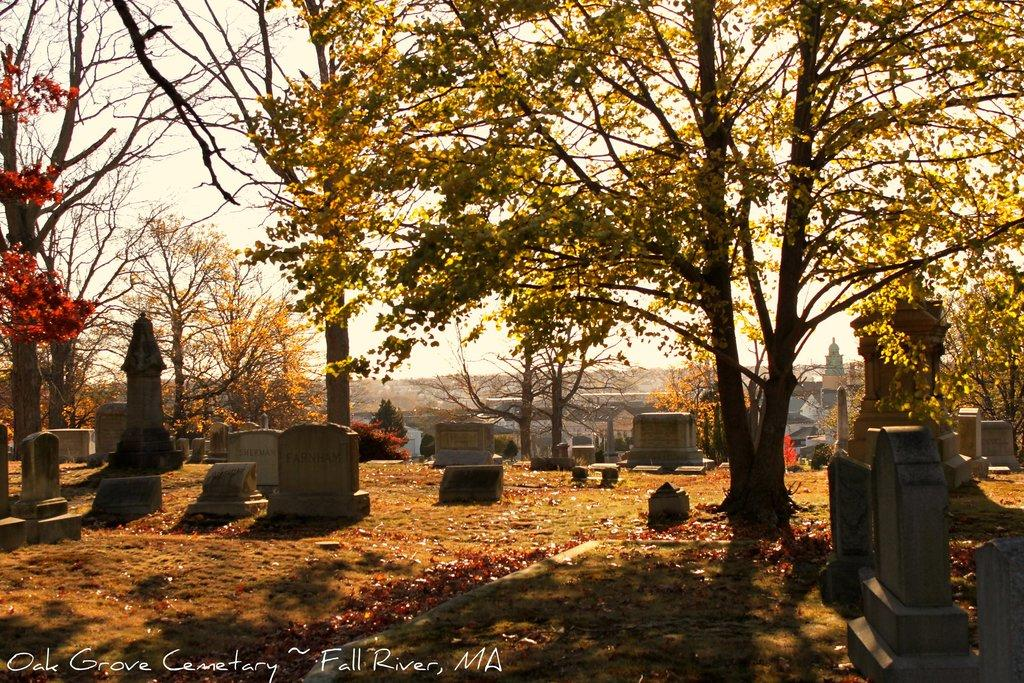What type of location is depicted in the image? The image contains cemeteries. What natural elements can be seen in the image? There are trees and grass visible in the image. What type of structures are in the background of the image? There are houses in the background of the image. What additional details can be observed at the bottom of the image? There are dry leaves at the bottom of the image. What is visible at the top of the image? The sky is visible at the top of the image. What type of cheese is being served by the secretary in the image? There is no secretary or cheese present in the image. Is there a van parked near the cemeteries in the image? There is no van visible in the image. 